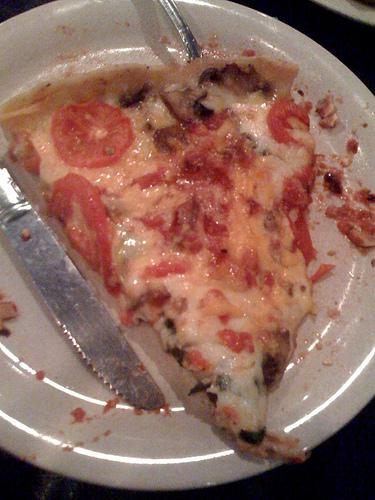How would you evaluate the overall presentation and quality of the image? The overall presentation and quality of the image is casual and a bit messy, with sauce dripping on the plate and objects placed irregularly. Estimate the number of different types of toppings on the pizza. There are at least 4 different types of toppings: tomato, mushroom, olive, and cheese. Identify the number of main components in the image and briefly describe each. There are 7 main components: 1) pizza on the plate, 2) knife next to the pizza, 3) fork under the pizza, 4) handle of the fork, 5) handle of the knife, 6) white round plate, and 7) table next to the plate. What type of food is being served and what are the key elements of the dish? The food served is a slice of thin crust pizza on a white round plate, with tomato, mushrooms, olives, cheese, and sauce as key elements of the dish. Determine the type of reasoning needed to understand the objects and their relationships in the image. Complex reasoning is needed to understand the objects and their relationships, as it requires comprehending the function or purpose of objects like forks, knives, plates, and identifying how they relate to each other and the main dish of pizza. Analyze the emotions and sentiments evoked by this image. The image might evoke feelings of hunger or satisfaction - the dish appears delicious and served quite casually, indicating a cozy atmosphere. Count the total number of objects mentioned in the image's descriptions. There are a total of 48 objects mentioned in the image descriptions. Can you detect an interaction between the objects in the image? The fork underneath the pizza seems to be interacting with the pizza, as it's meant to be used for eating purposes. The knife next to the pizza also suggests an intention to cut or hold the pizza slice. Explain the positioning of different objects around the main dish on the plate. A silver knife with a serrated edge is on the left side of the plate close to the pizza, and the tip of a fork is under the slice of pizza. Describe any two elements of the pizza slice in the image and the role they play. Tomato slices and mushrooms are two elements of the pizza that act as toppings, offering additional flavors and textures to the dish. 